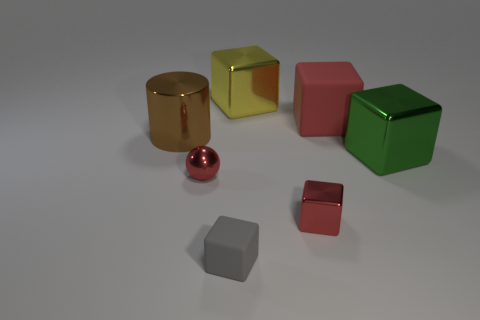Add 3 matte blocks. How many objects exist? 10 Subtract all balls. How many objects are left? 6 Add 7 metallic blocks. How many metallic blocks are left? 10 Add 1 small purple rubber things. How many small purple rubber things exist? 1 Subtract 0 purple cylinders. How many objects are left? 7 Subtract all big green metal spheres. Subtract all metal cubes. How many objects are left? 4 